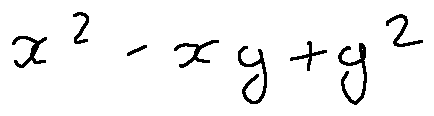<formula> <loc_0><loc_0><loc_500><loc_500>x ^ { 2 } - x y + y ^ { 2 }</formula> 